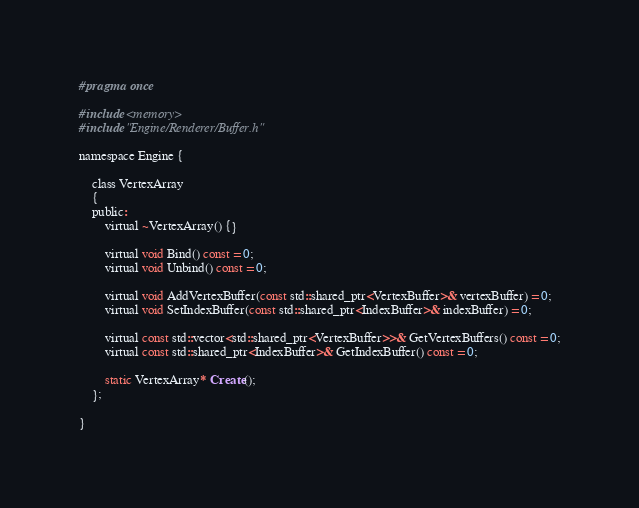<code> <loc_0><loc_0><loc_500><loc_500><_C_>#pragma once

#include <memory>
#include "Engine/Renderer/Buffer.h"

namespace Engine {

	class VertexArray
	{
	public:
		virtual ~VertexArray() {}

		virtual void Bind() const = 0;
		virtual void Unbind() const = 0;

		virtual void AddVertexBuffer(const std::shared_ptr<VertexBuffer>& vertexBuffer) = 0;
		virtual void SetIndexBuffer(const std::shared_ptr<IndexBuffer>& indexBuffer) = 0;

		virtual const std::vector<std::shared_ptr<VertexBuffer>>& GetVertexBuffers() const = 0;
		virtual const std::shared_ptr<IndexBuffer>& GetIndexBuffer() const = 0;

		static VertexArray* Create();
	};

}
</code> 